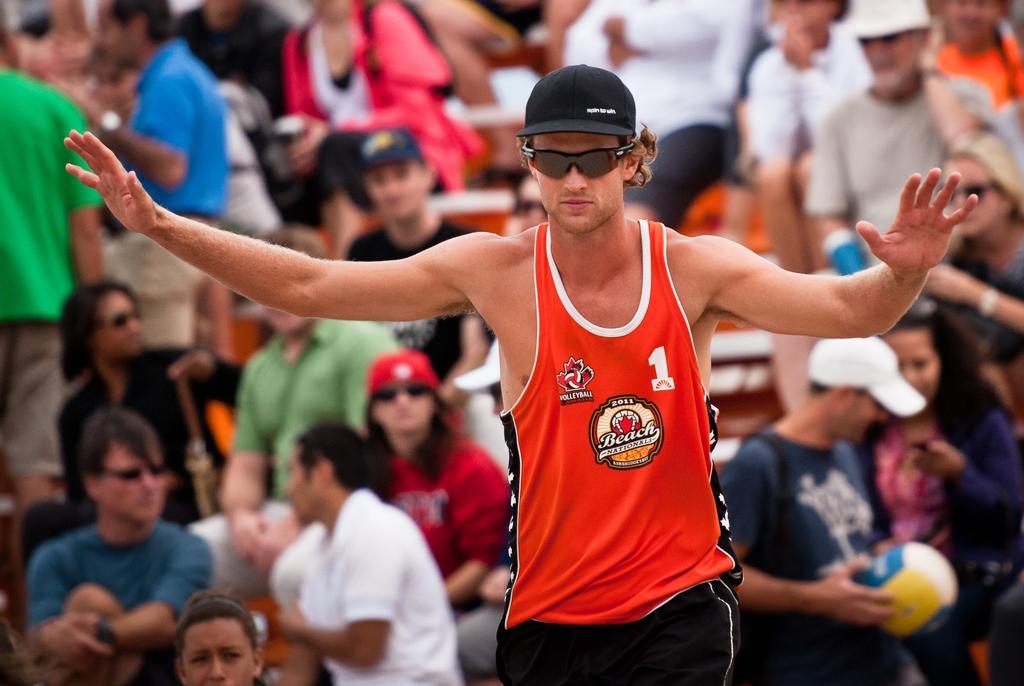Can you describe this image briefly? In this image I can see few persons, some are sitting and some are standing. In front the person is wearing black, white and red color dress and the person is also wearing black color cap. 